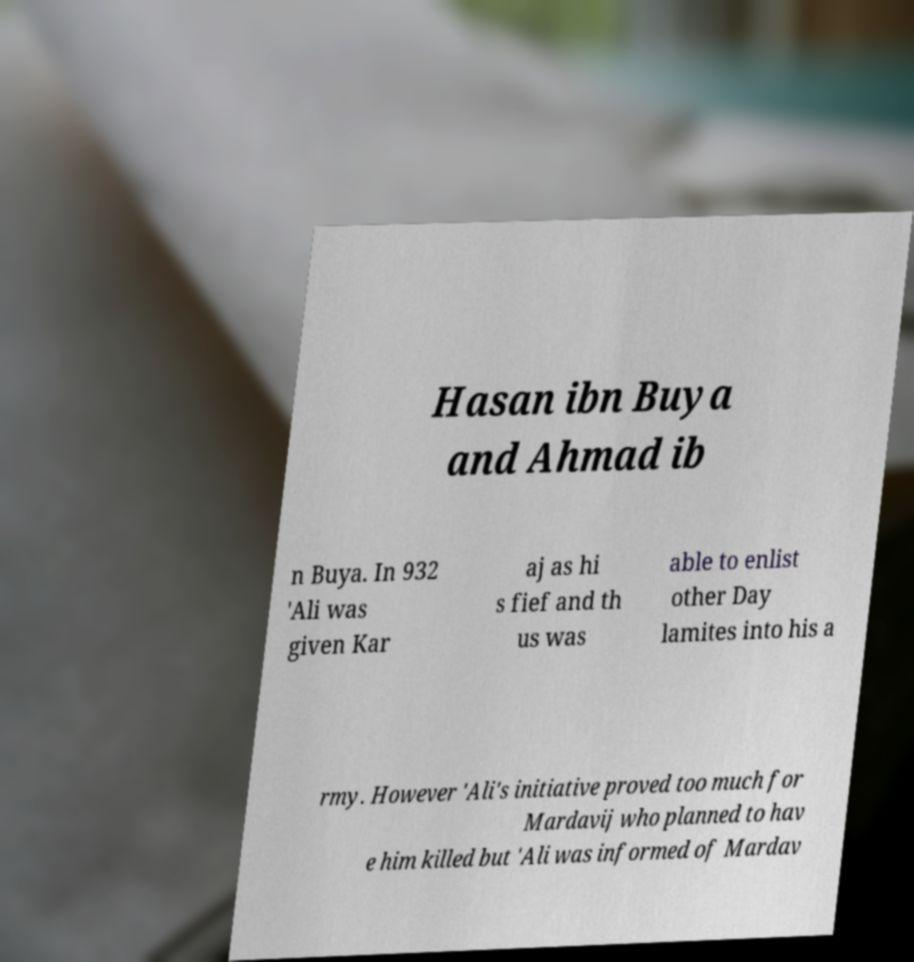I need the written content from this picture converted into text. Can you do that? Hasan ibn Buya and Ahmad ib n Buya. In 932 'Ali was given Kar aj as hi s fief and th us was able to enlist other Day lamites into his a rmy. However 'Ali's initiative proved too much for Mardavij who planned to hav e him killed but 'Ali was informed of Mardav 